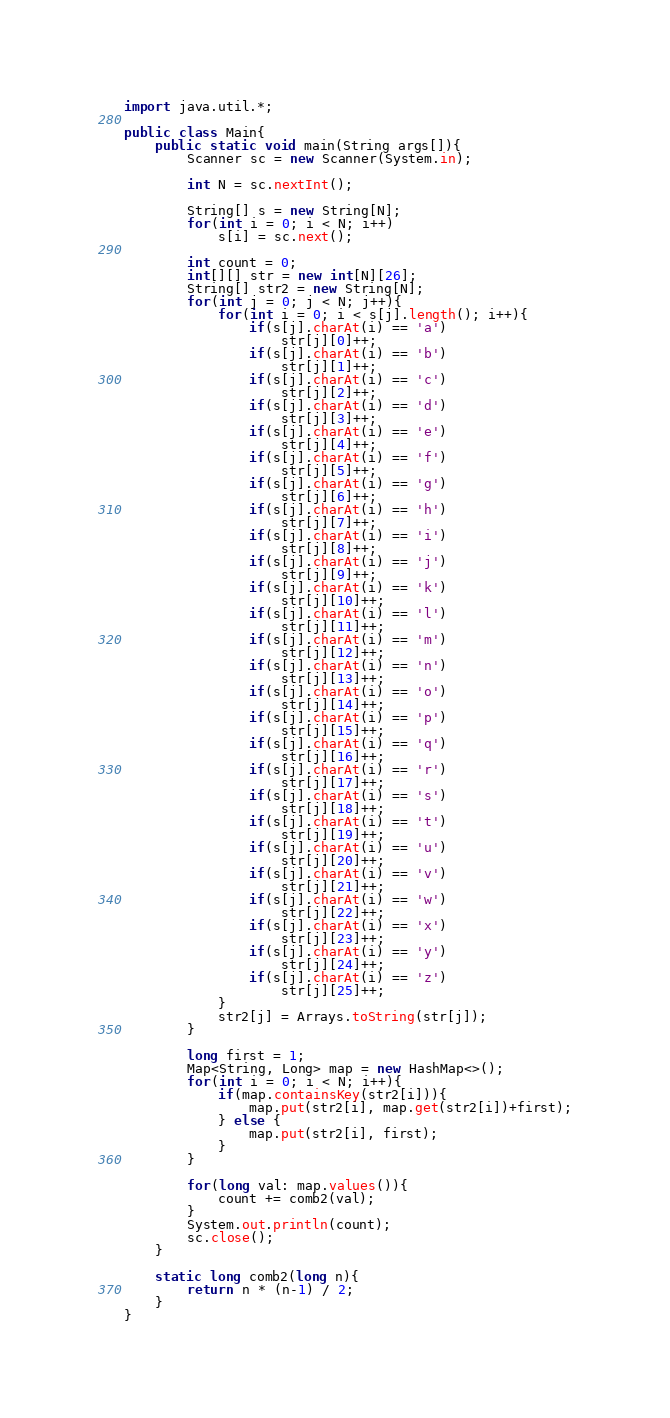<code> <loc_0><loc_0><loc_500><loc_500><_Java_>import java.util.*;

public class Main{
    public static void main(String args[]){
        Scanner sc = new Scanner(System.in);
        
        int N = sc.nextInt();

        String[] s = new String[N];
        for(int i = 0; i < N; i++)
            s[i] = sc.next();       
        
        int count = 0;
        int[][] str = new int[N][26];
        String[] str2 = new String[N];
        for(int j = 0; j < N; j++){
            for(int i = 0; i < s[j].length(); i++){
                if(s[j].charAt(i) == 'a')
                    str[j][0]++;
                if(s[j].charAt(i) == 'b')
                    str[j][1]++;
                if(s[j].charAt(i) == 'c')
                    str[j][2]++;
                if(s[j].charAt(i) == 'd')
                    str[j][3]++;
                if(s[j].charAt(i) == 'e')
                    str[j][4]++;
                if(s[j].charAt(i) == 'f')
                    str[j][5]++;
                if(s[j].charAt(i) == 'g')
                    str[j][6]++;
                if(s[j].charAt(i) == 'h')
                    str[j][7]++;
                if(s[j].charAt(i) == 'i')
                    str[j][8]++;
                if(s[j].charAt(i) == 'j')
                    str[j][9]++;
                if(s[j].charAt(i) == 'k')
                    str[j][10]++;
                if(s[j].charAt(i) == 'l')
                    str[j][11]++;
                if(s[j].charAt(i) == 'm')
                    str[j][12]++;
                if(s[j].charAt(i) == 'n')
                    str[j][13]++;
                if(s[j].charAt(i) == 'o')
                    str[j][14]++;
                if(s[j].charAt(i) == 'p')
                    str[j][15]++;
                if(s[j].charAt(i) == 'q')
                    str[j][16]++;
                if(s[j].charAt(i) == 'r')
                    str[j][17]++;
                if(s[j].charAt(i) == 's')
                    str[j][18]++;
                if(s[j].charAt(i) == 't')
                    str[j][19]++;
                if(s[j].charAt(i) == 'u')
                    str[j][20]++;
                if(s[j].charAt(i) == 'v')
                    str[j][21]++;
                if(s[j].charAt(i) == 'w')
                    str[j][22]++;
                if(s[j].charAt(i) == 'x')
                    str[j][23]++;
                if(s[j].charAt(i) == 'y')
                    str[j][24]++;
                if(s[j].charAt(i) == 'z')
                    str[j][25]++; 
            }
            str2[j] = Arrays.toString(str[j]);
        }

        long first = 1;
        Map<String, Long> map = new HashMap<>();
        for(int i = 0; i < N; i++){
            if(map.containsKey(str2[i])){
                map.put(str2[i], map.get(str2[i])+first);
            } else {
                map.put(str2[i], first);
            }
        }

        for(long val: map.values()){
            count += comb2(val);
        }
        System.out.println(count);
        sc.close();
    }

    static long comb2(long n){
        return n * (n-1) / 2;
    }
}
</code> 